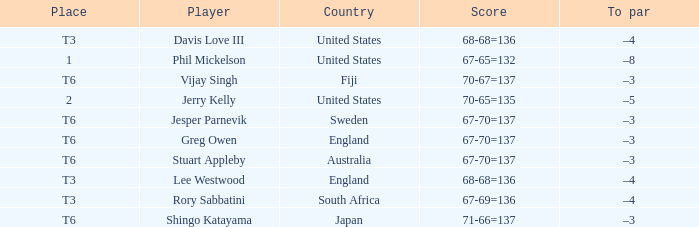Name the player for fiji Vijay Singh. 